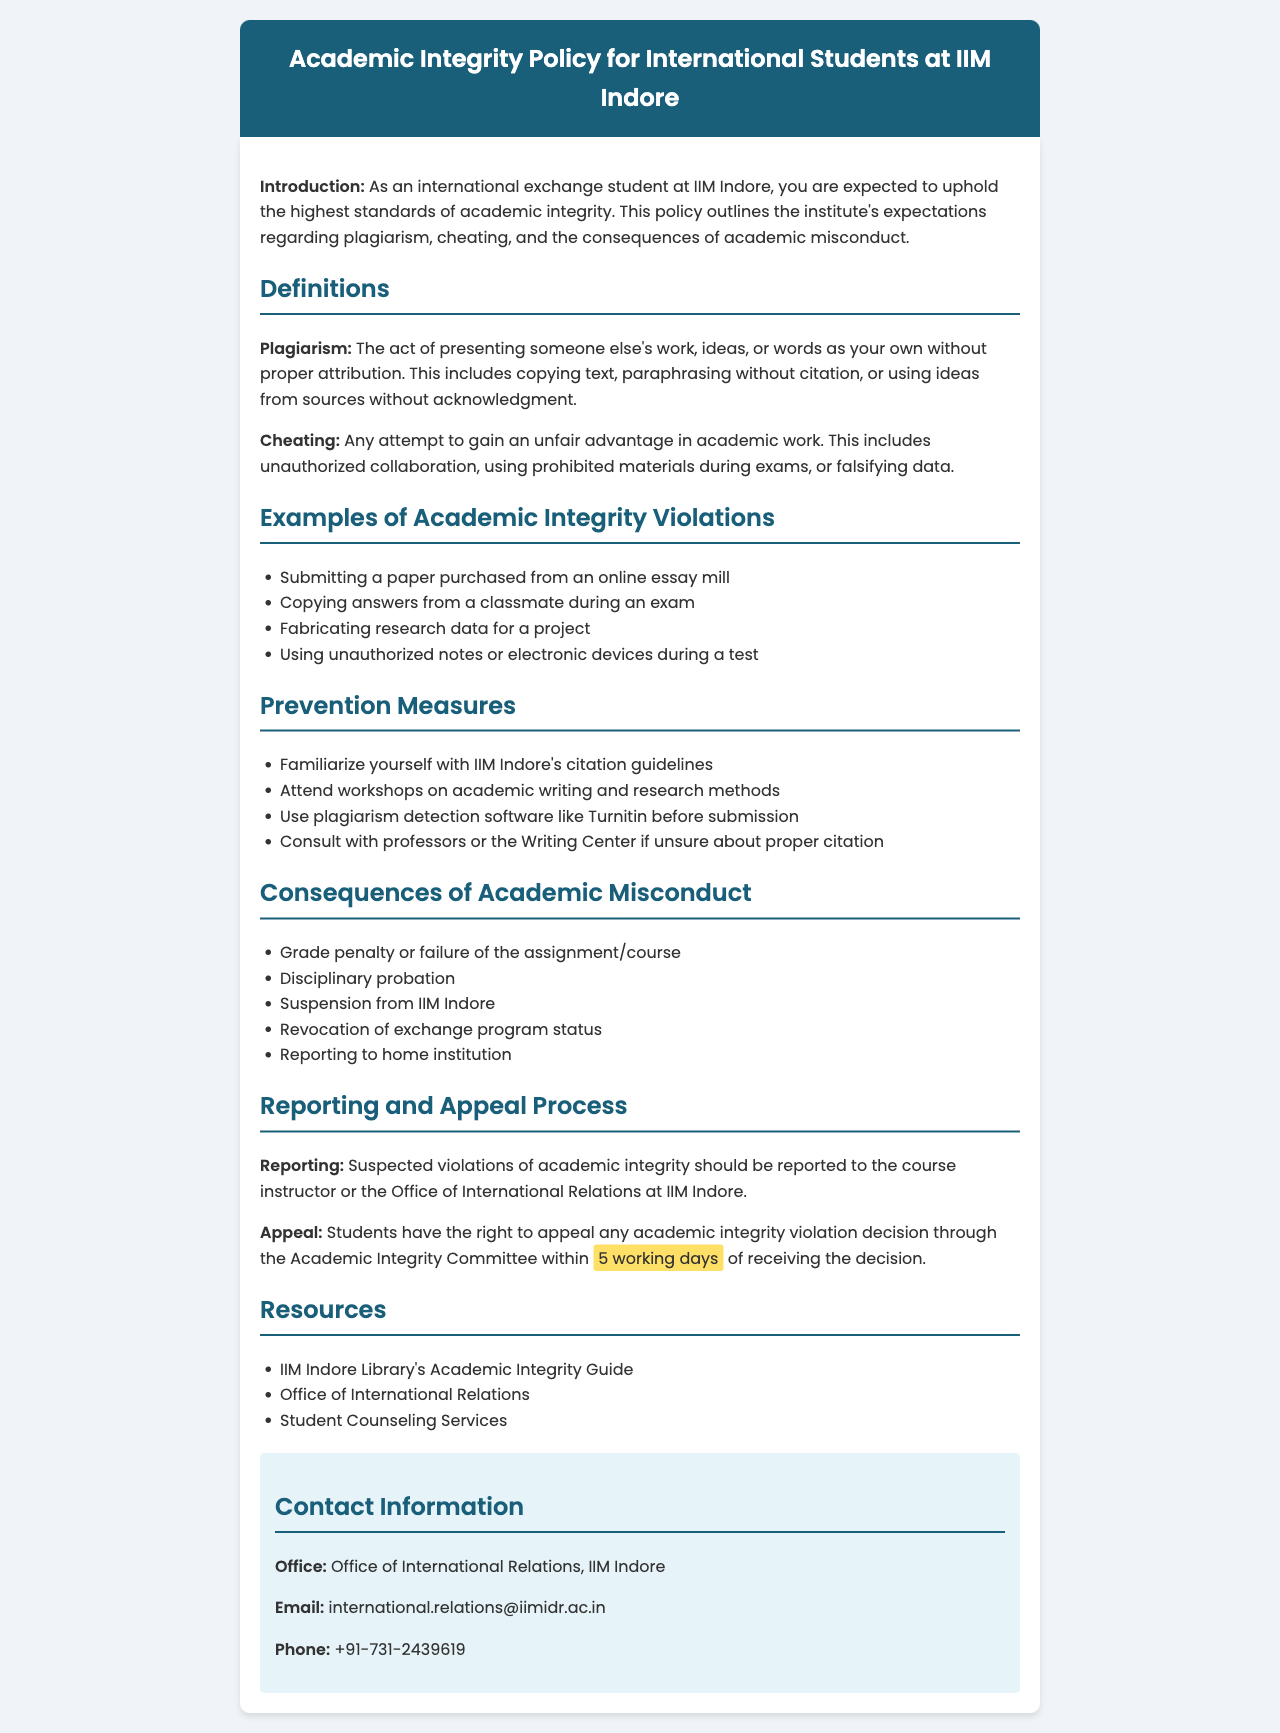What defines plagiarism in this document? Plagiarism is defined as presenting someone else's work, ideas, or words as your own without proper attribution.
Answer: Presenting someone else's work, ideas, or words as your own without proper attribution What is an example of cheating? Cheating is defined as any attempt to gain an unfair advantage in academic work.
Answer: Any attempt to gain an unfair advantage in academic work What is the consequence for failing an assignment due to academic misconduct? The document specifies that one of the consequences is a grade penalty or failure of the assignment/course.
Answer: Grade penalty or failure of the assignment/course How long do students have to appeal a decision on academic integrity violations? Students have the right to appeal any academic integrity violation decision within a specific timeframe.
Answer: 5 working days Where should suspected violations of academic integrity be reported? The document states that suspected violations should be reported to a specific entity.
Answer: Course instructor or the Office of International Relations What resource is available to help with academic integrity? The document lists several resources, one of which can be associated with academic integrity guidance.
Answer: IIM Indore Library's Academic Integrity Guide What is one prevention measure suggested in the document? The document includes suggestions for preventing academic misconduct and one specific action is to be familiar with citation guidelines.
Answer: Familiarize yourself with IIM Indore's citation guidelines What is a potential consequence specifically mentioned for international students? The document indicates a specific consequence that relates directly to international exchange students.
Answer: Revocation of exchange program status 